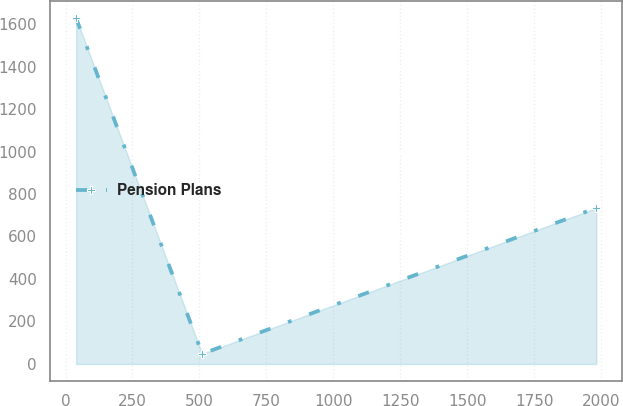Convert chart. <chart><loc_0><loc_0><loc_500><loc_500><line_chart><ecel><fcel>Pension Plans<nl><fcel>39.58<fcel>1627.41<nl><fcel>510.42<fcel>47.64<nl><fcel>1981.91<fcel>734.27<nl></chart> 